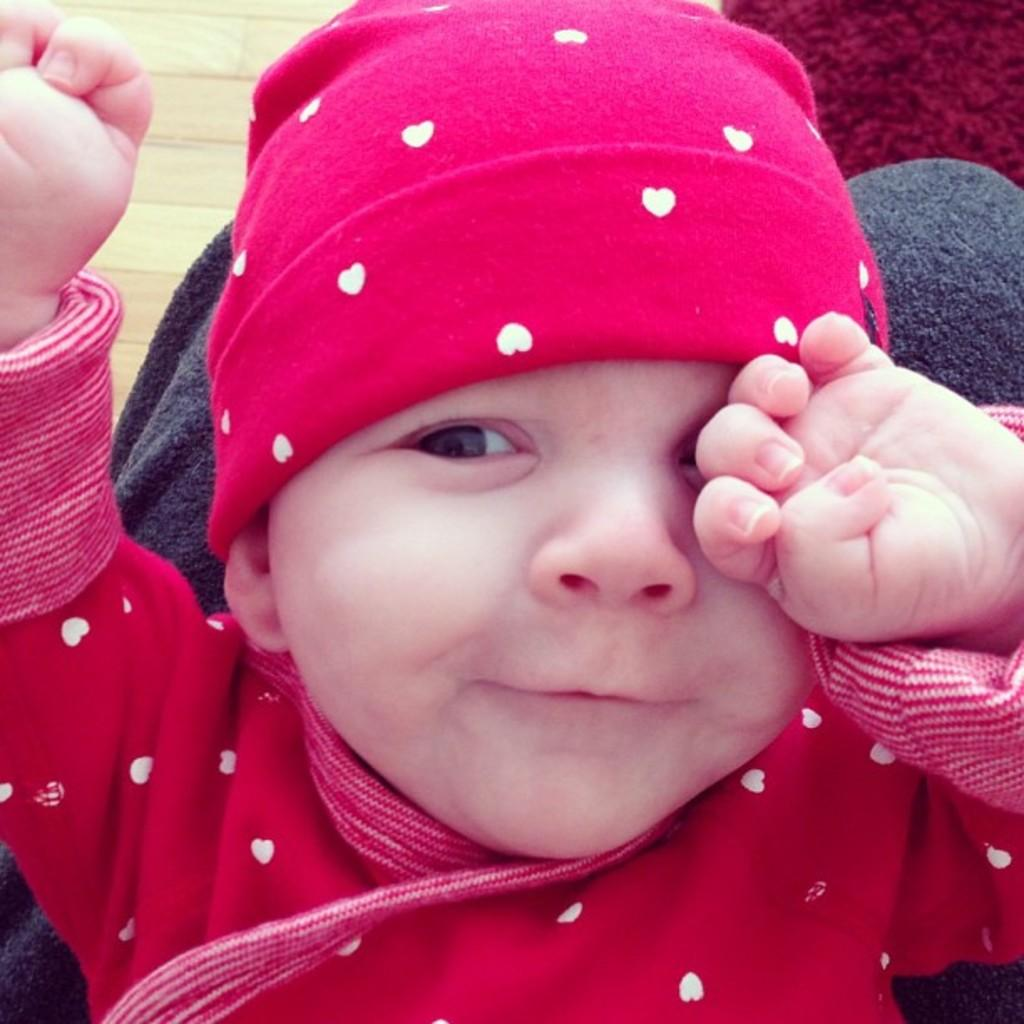What is the main subject of the image? There is a baby in the image. What is the baby doing in the image? The baby is smiling. What type of jellyfish can be seen swimming in the background of the image? There is no jellyfish present in the image; it features a baby who is smiling. 